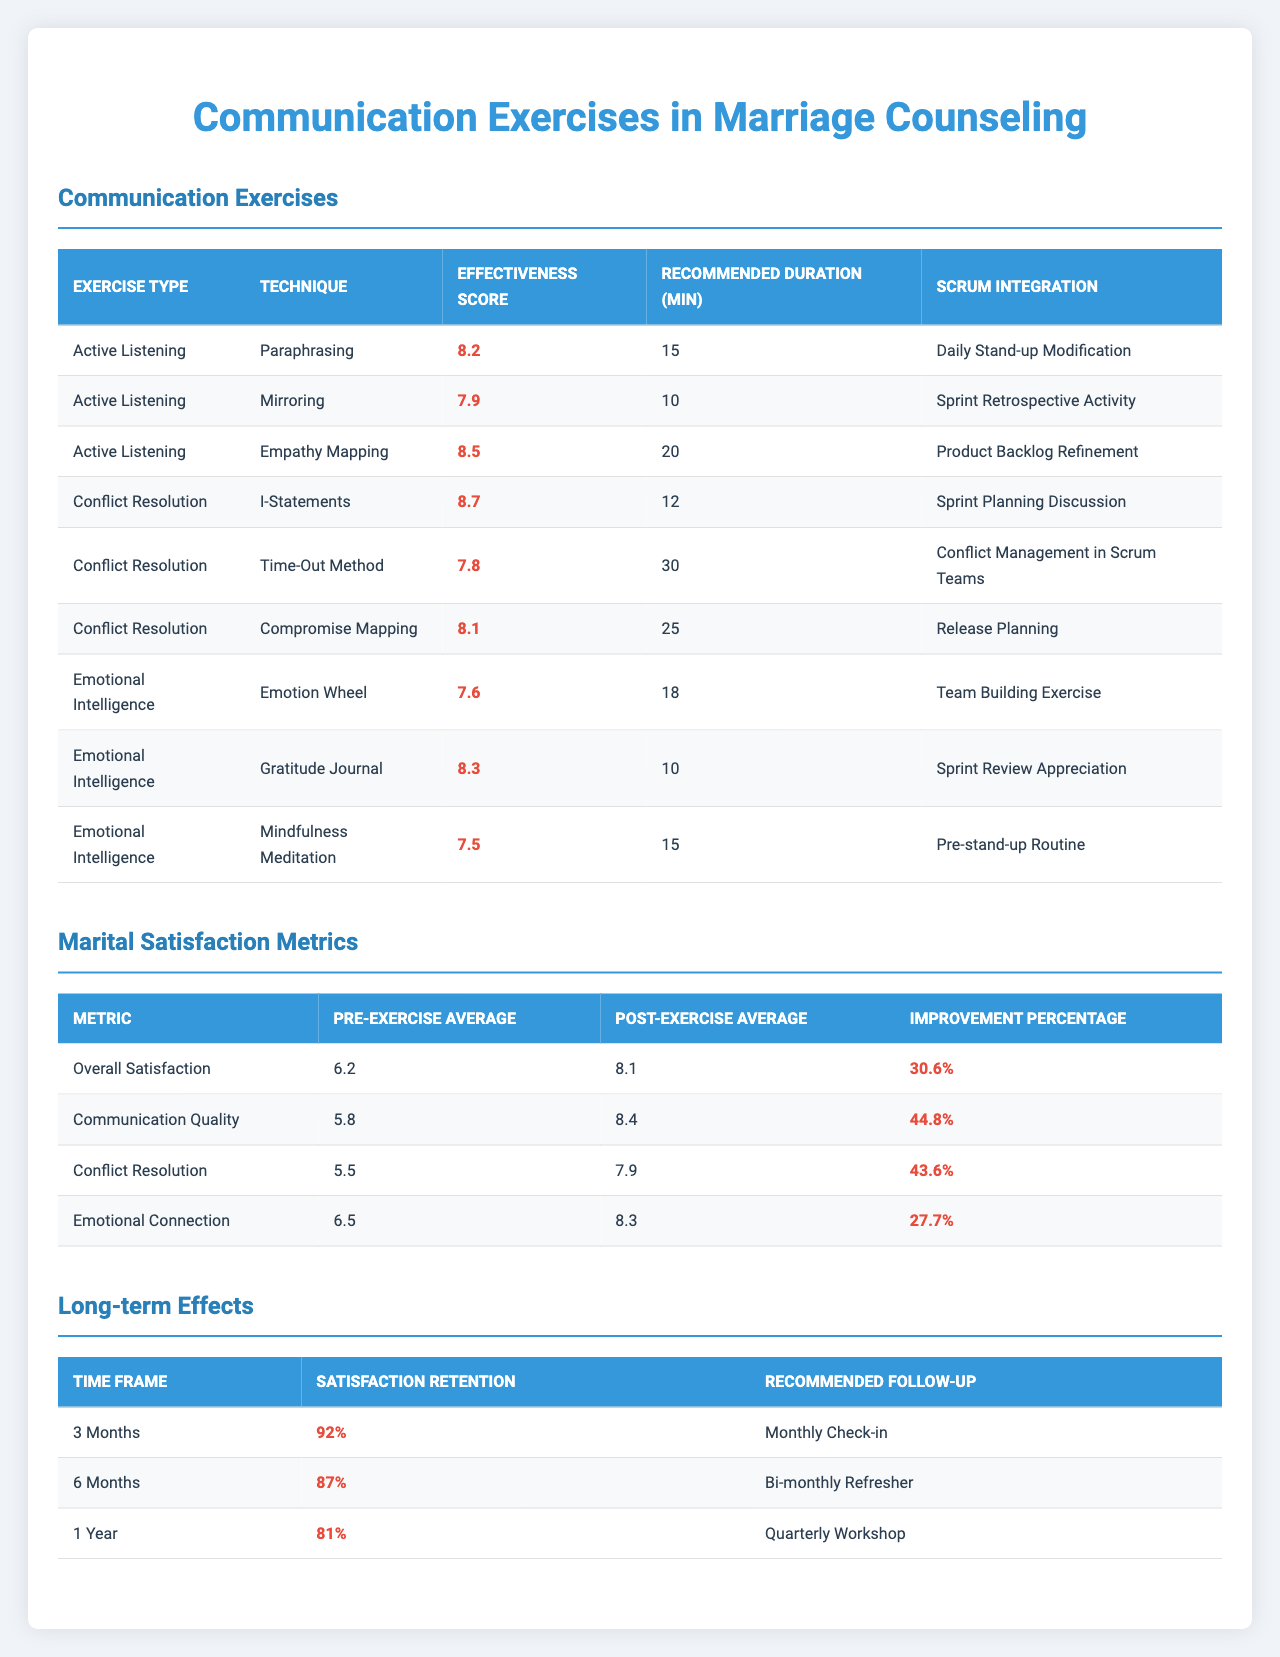What is the effectiveness score of the "Mirroring" technique? The effectiveness score of the "Mirroring" technique is listed in the "Communication Exercises" section of the table. It is 7.9.
Answer: 7.9 What is the recommended duration for the "Empathy Mapping" exercise? The recommended duration is provided in the table for each exercise. For "Empathy Mapping," the duration is 20 minutes.
Answer: 20 minutes Which exercise type has the highest effectiveness score? To determine this, we compare the effectiveness scores from all exercise types. The "I-Statements" technique from the "Conflict Resolution" exercise type has the highest score at 8.7.
Answer: "I-Statements" What is the improvement percentage for "Communication Quality"? The improvement percentage is directly provided for each metric in the "Marital Satisfaction Metrics" section. For "Communication Quality," it is 44.8%.
Answer: 44.8% What is the pre-exercise average for "Emotional Connection"? The pre-exercise average for "Emotional Connection" is given in the "Marital Satisfaction Metrics" section. It is 6.5.
Answer: 6.5 Which technique recommended for "Conflict Resolution" has the shortest recommended duration? We look at the recommended duration for each technique under "Conflict Resolution." The "I-Statements" technique has the shortest duration of 12 minutes.
Answer: "I-Statements" How much did the overall satisfaction score improve after the exercises? The improvement in overall satisfaction is found by looking at the pre-exercise and post-exercise averages in the "Marital Satisfaction Metrics." The score improved from 6.2 to 8.1, resulting in an improvement of 30.6%.
Answer: 30.6% What is the average effectiveness score of all the techniques listed under "Active Listening"? The effectiveness scores for the techniques in "Active Listening" are 8.2 (Paraphrasing), 7.9 (Mirroring), and 8.5 (Empathy Mapping). Their sum is 24.6, divided by 3 techniques, gives an average of 8.2.
Answer: 8.2 Which long-term effect has the lowest satisfaction retention, and what is the percentage? The satisfaction retention percentage for each time frame in the "Long-term Effects" section shows that the 1 Year timeframe has the lowest retention at 81%.
Answer: 81% Is the effectiveness of the "Gratitude Journal" higher than that of the "Emotion Wheel"? The effectiveness scores are 8.3 for the "Gratitude Journal" and 7.6 for the "Emotion Wheel." Since 8.3 is greater than 7.6, this statement is true.
Answer: Yes 